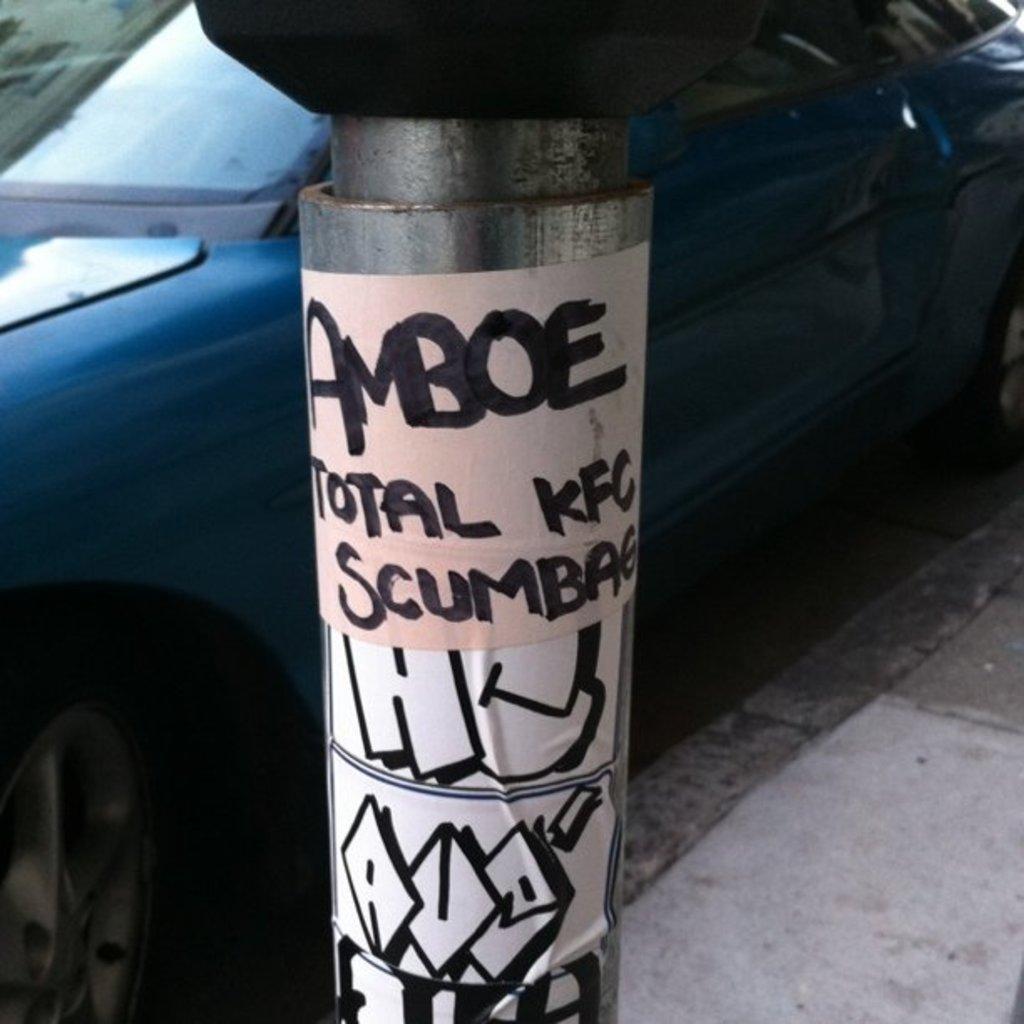Please provide a concise description of this image. In this image I can see the pole and I can see few papers attache to the pole and I can see something written on the paper. In the background I can see the car in blue color. 